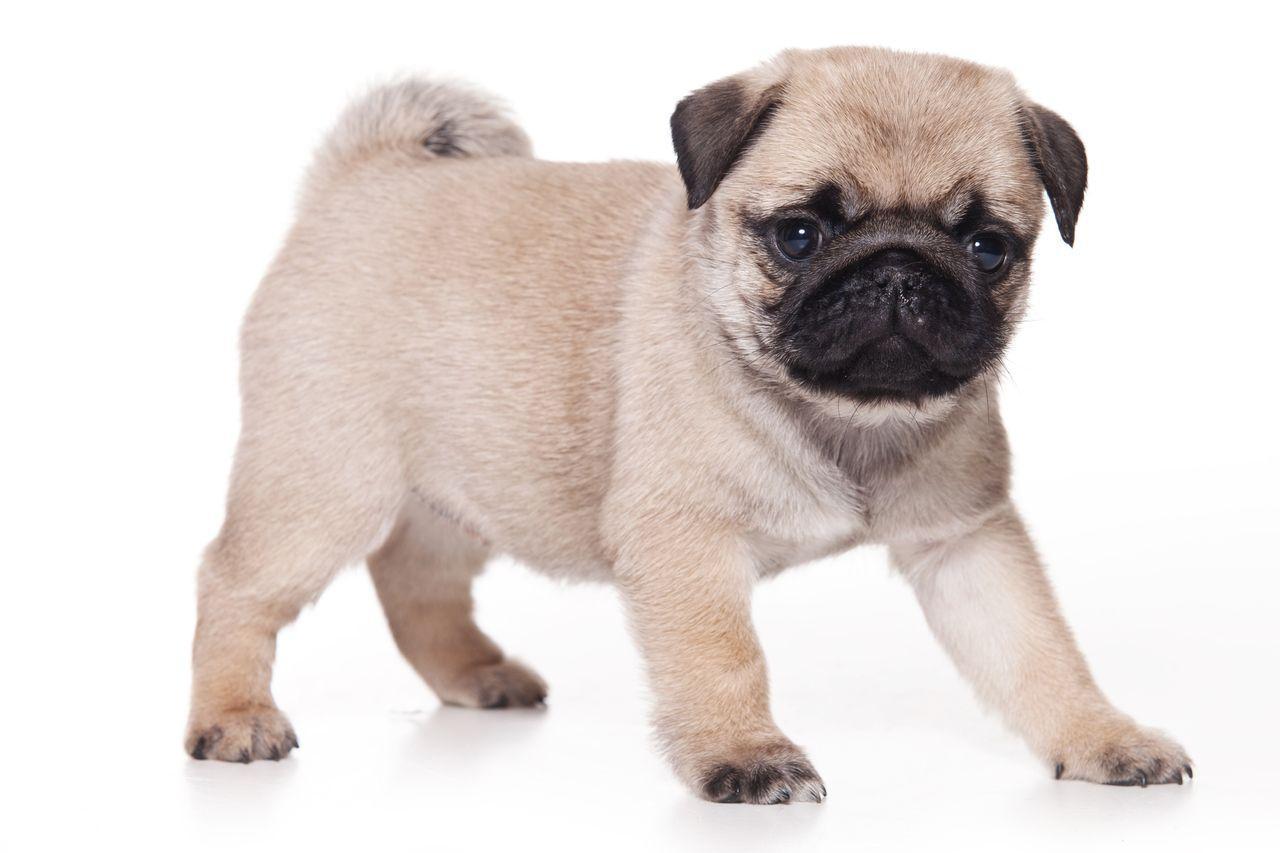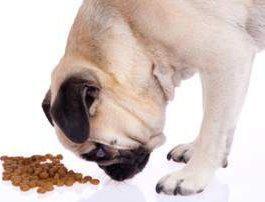The first image is the image on the left, the second image is the image on the right. Assess this claim about the two images: "There is no more than one dog in the left image and it has no dog food.". Correct or not? Answer yes or no. Yes. The first image is the image on the left, the second image is the image on the right. Considering the images on both sides, is "An image shows one pug dog with one pet food bowl." valid? Answer yes or no. No. 